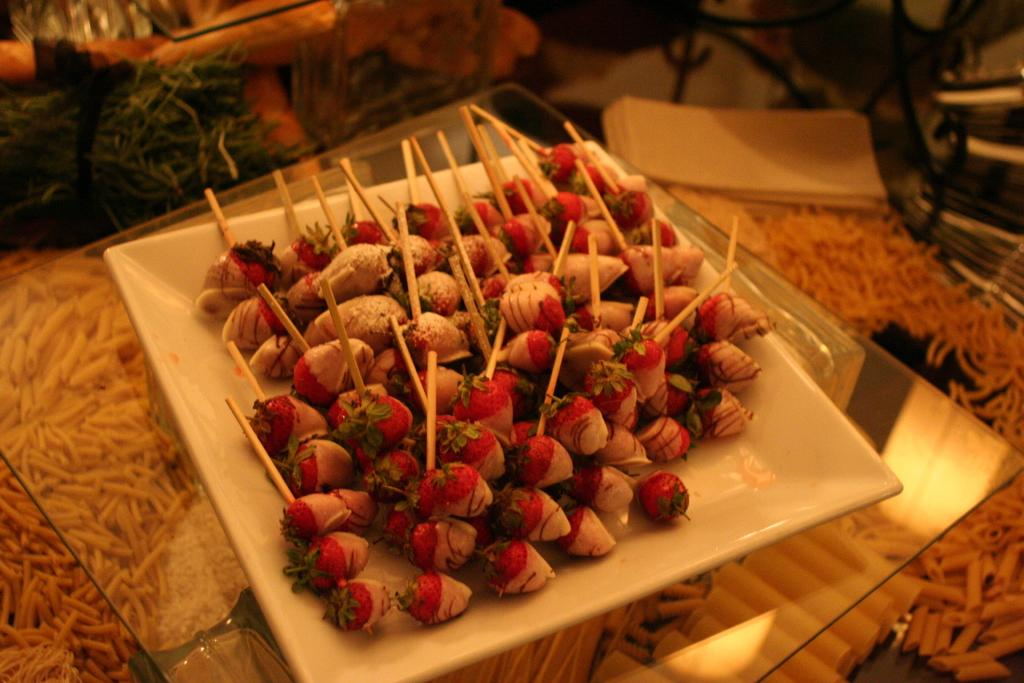What is on the plate that is visible in the image? The plate contains strawberries. Where is the plate located in the image? The plate is placed on a glass table. What type of flooring is visible in the image? There is a carpet in the image. What might be used to pick up the strawberries in the image? Toothpicks are present with the strawberries on the plate. How does the dog start the race in the image? There is no dog or race present in the image. 